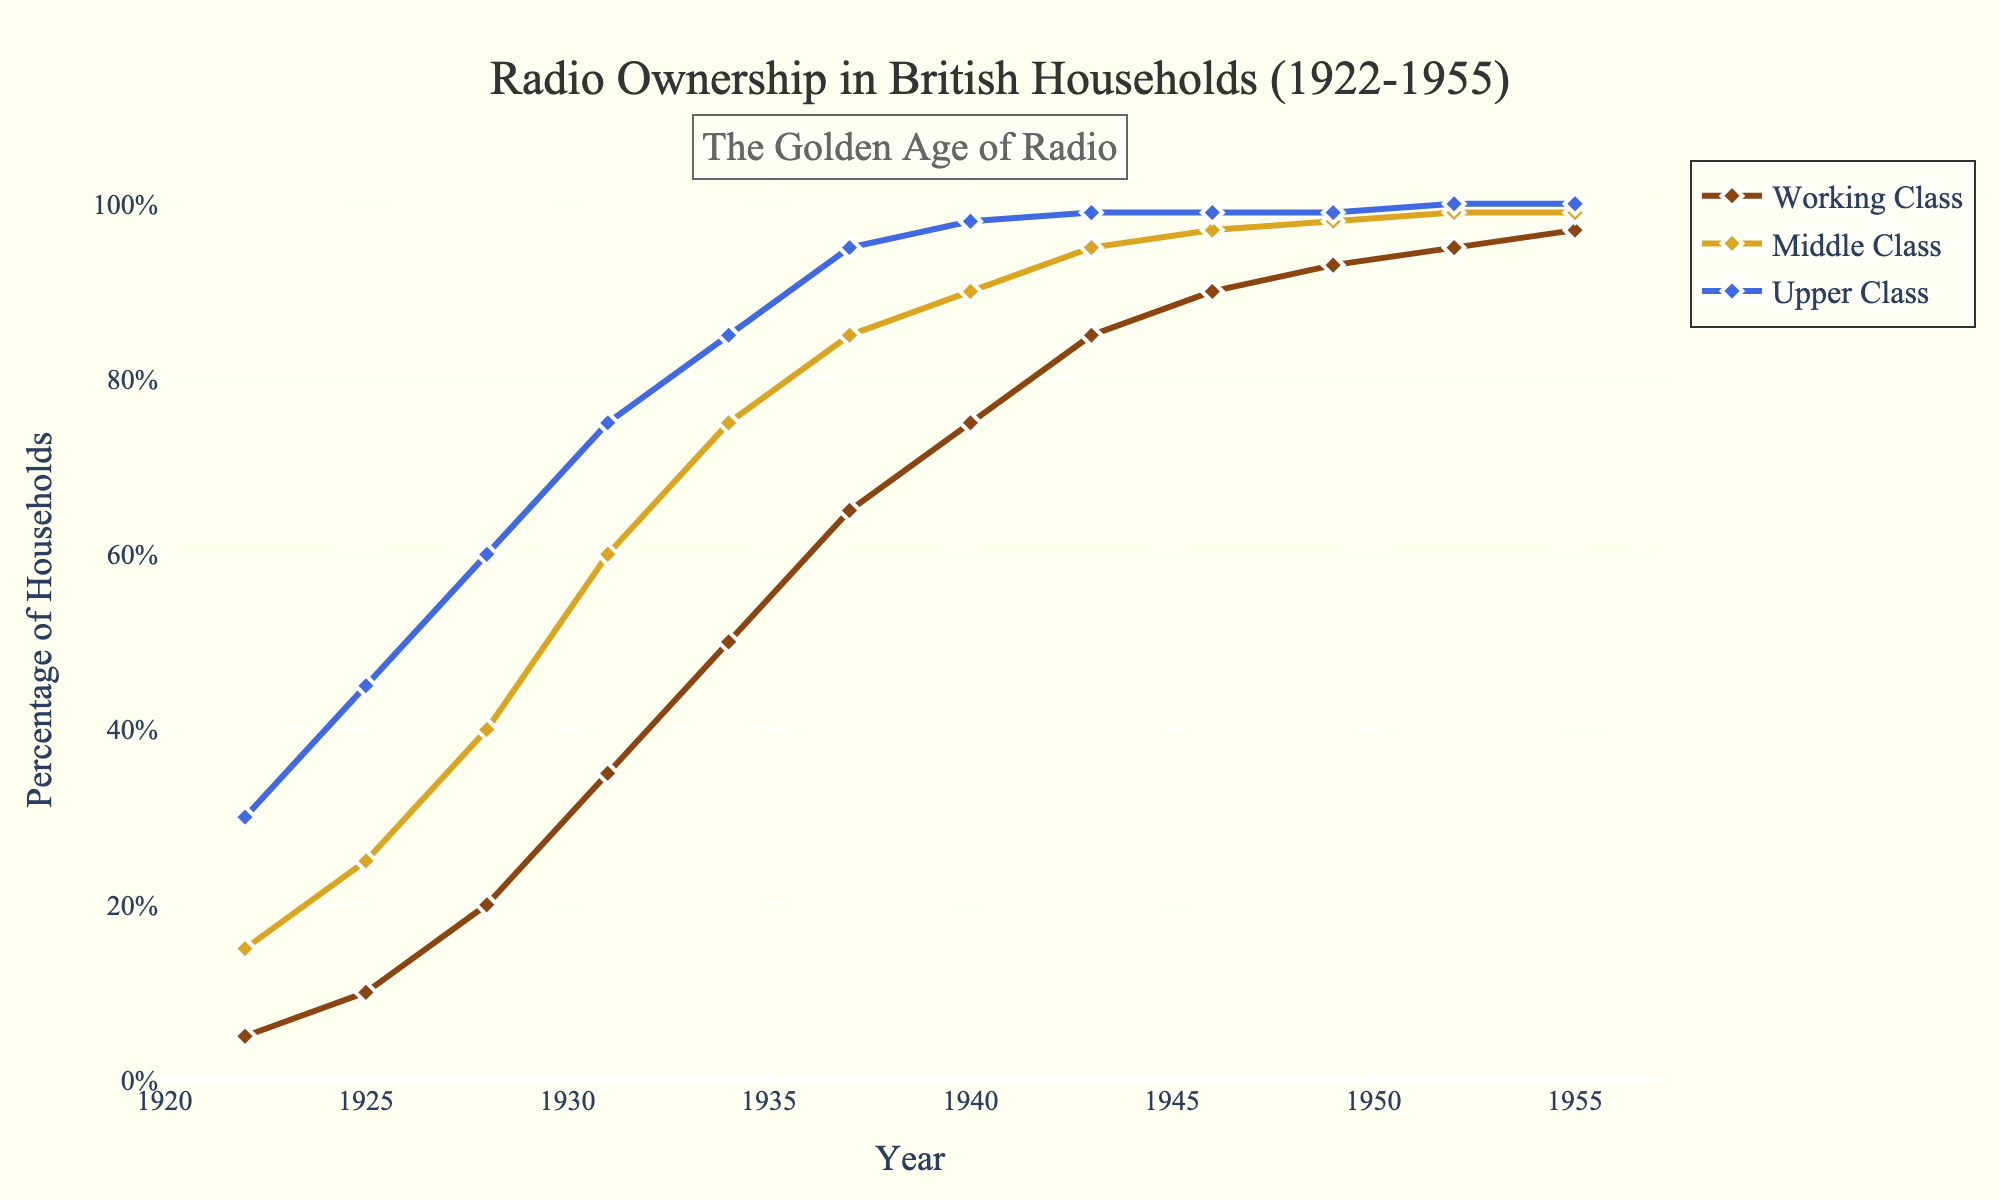What is the highest percentage of radio ownership by any class in 1922? The visual shows the percentage of radio ownership for all classes in 1922. The highest percentage is for the Upper Class, marked at 30%.
Answer: 30% How did the percentage of radio ownership in Upper Class homes change from 1922 to 1955? Comparing the data points for Upper Class homes in 1922 (30%) and 1955 (100%), the ownership increased by 70%.
Answer: Increased by 70% Which class saw the most significant growth in radio ownership between 1922 and 1955? By examining the values for all classes, Working Class radio ownership grew from 5% in 1922 to 97% in 1955, the most significant increase of 92%.
Answer: Working Class In what year did all classes have at least 75% radio ownership? The visual shows that in 1937, all classes had at least 75% ownership: Working Class (65%), Middle Class (85%), and Upper Class (95%). The next data point (1940): Working Class reached 75%. Thus, 1940 is the answer.
Answer: 1940 What is the difference in radio ownership between Middle Class and Working Class in 1931? In 1931, the Middle Class had 60% ownership, and the Working Class had 35% ownership. The difference is 60% - 35% = 25%.
Answer: 25% How did radio ownership in Middle Class homes change between 1940 and 1949? In 1940, Middle Class ownership was at 90%, and by 1949, it reached 98%. The change is 98% - 90% = 8%.
Answer: Increased by 8% Which socioeconomic class reached 100% radio ownership first, and in what year? The visual shows that the Upper Class reached 100% radio ownership first in 1952.
Answer: Upper Class in 1952 What is the average percentage of radio ownership for the Middle Class between 1922 and 1955? Sum the Middle Class percentages: 15, 25, 40, 60, 75, 85, 90, 95, 97, 98, 99, 99. The sum is 878. Divide by the number of years (12): average = 878 / 12 = 73.17%.
Answer: 73.17% In 1949, what was the percentage difference in radio ownership between the Middle and Upper Classes? In 1949, Middle Class ownership was 98% and Upper Class was 99%. The difference is 99% - 98% = 1%.
Answer: 1% 